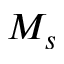<formula> <loc_0><loc_0><loc_500><loc_500>M _ { s }</formula> 